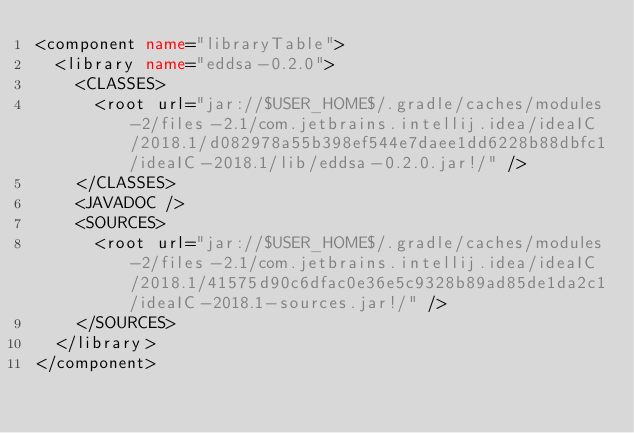<code> <loc_0><loc_0><loc_500><loc_500><_XML_><component name="libraryTable">
  <library name="eddsa-0.2.0">
    <CLASSES>
      <root url="jar://$USER_HOME$/.gradle/caches/modules-2/files-2.1/com.jetbrains.intellij.idea/ideaIC/2018.1/d082978a55b398ef544e7daee1dd6228b88dbfc1/ideaIC-2018.1/lib/eddsa-0.2.0.jar!/" />
    </CLASSES>
    <JAVADOC />
    <SOURCES>
      <root url="jar://$USER_HOME$/.gradle/caches/modules-2/files-2.1/com.jetbrains.intellij.idea/ideaIC/2018.1/41575d90c6dfac0e36e5c9328b89ad85de1da2c1/ideaIC-2018.1-sources.jar!/" />
    </SOURCES>
  </library>
</component></code> 